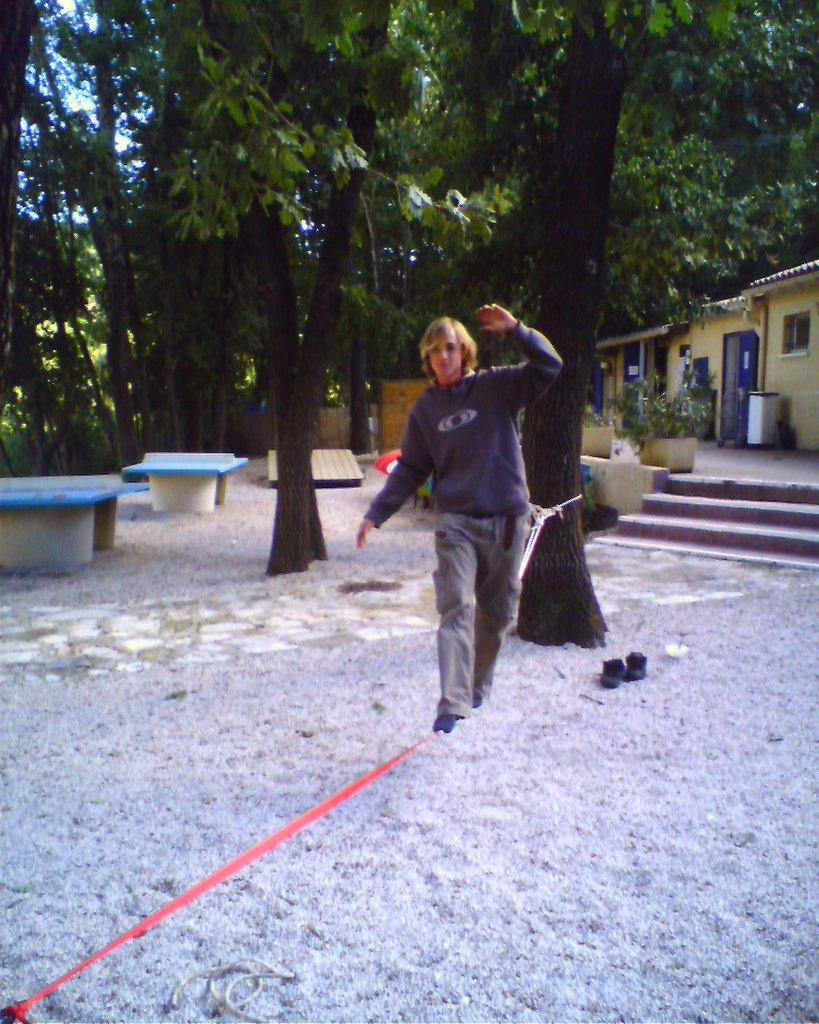What is the main subject of the image? There is a person standing in the image. What type of natural elements can be seen in the image? There are trees in the image. What type of man-made structures are present in the image? There are buildings in the image. What type of decorative objects can be seen in the image? There are flowerpots in the image. What architectural feature is present in the image? There are stairs in the image. What type of seating is available in the image? There are benches in the image. What else can be seen in the image besides the mentioned objects? There are other objects in the image. What is visible in the background of the image? The sky is visible in the image. What is the title of the book the horse is reading in the image? There is no horse or book present in the image; it features a person standing with various objects and structures around them. 